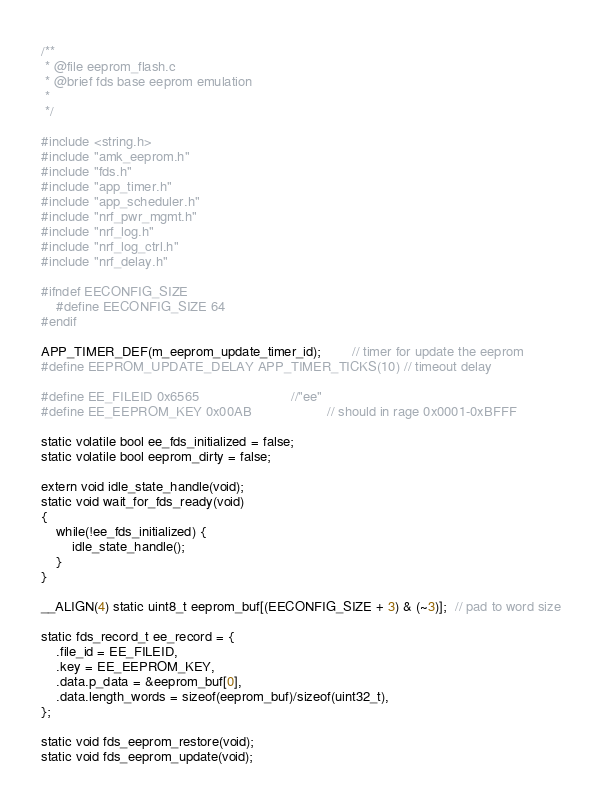<code> <loc_0><loc_0><loc_500><loc_500><_C_>/**
 * @file eeprom_flash.c
 * @brief fds base eeprom emulation
 *
 */

#include <string.h>
#include "amk_eeprom.h"
#include "fds.h"
#include "app_timer.h"
#include "app_scheduler.h"
#include "nrf_pwr_mgmt.h"
#include "nrf_log.h"
#include "nrf_log_ctrl.h"
#include "nrf_delay.h"

#ifndef EECONFIG_SIZE
    #define EECONFIG_SIZE 64
#endif

APP_TIMER_DEF(m_eeprom_update_timer_id);        // timer for update the eeprom
#define EEPROM_UPDATE_DELAY APP_TIMER_TICKS(10) // timeout delay

#define EE_FILEID 0x6565                        //"ee"
#define EE_EEPROM_KEY 0x00AB                    // should in rage 0x0001-0xBFFF

static volatile bool ee_fds_initialized = false;
static volatile bool eeprom_dirty = false;

extern void idle_state_handle(void);
static void wait_for_fds_ready(void)
{
    while(!ee_fds_initialized) {
        idle_state_handle();
    }
}

__ALIGN(4) static uint8_t eeprom_buf[(EECONFIG_SIZE + 3) & (~3)];  // pad to word size

static fds_record_t ee_record = {
    .file_id = EE_FILEID,
    .key = EE_EEPROM_KEY,
    .data.p_data = &eeprom_buf[0],
    .data.length_words = sizeof(eeprom_buf)/sizeof(uint32_t),
};

static void fds_eeprom_restore(void);
static void fds_eeprom_update(void);</code> 